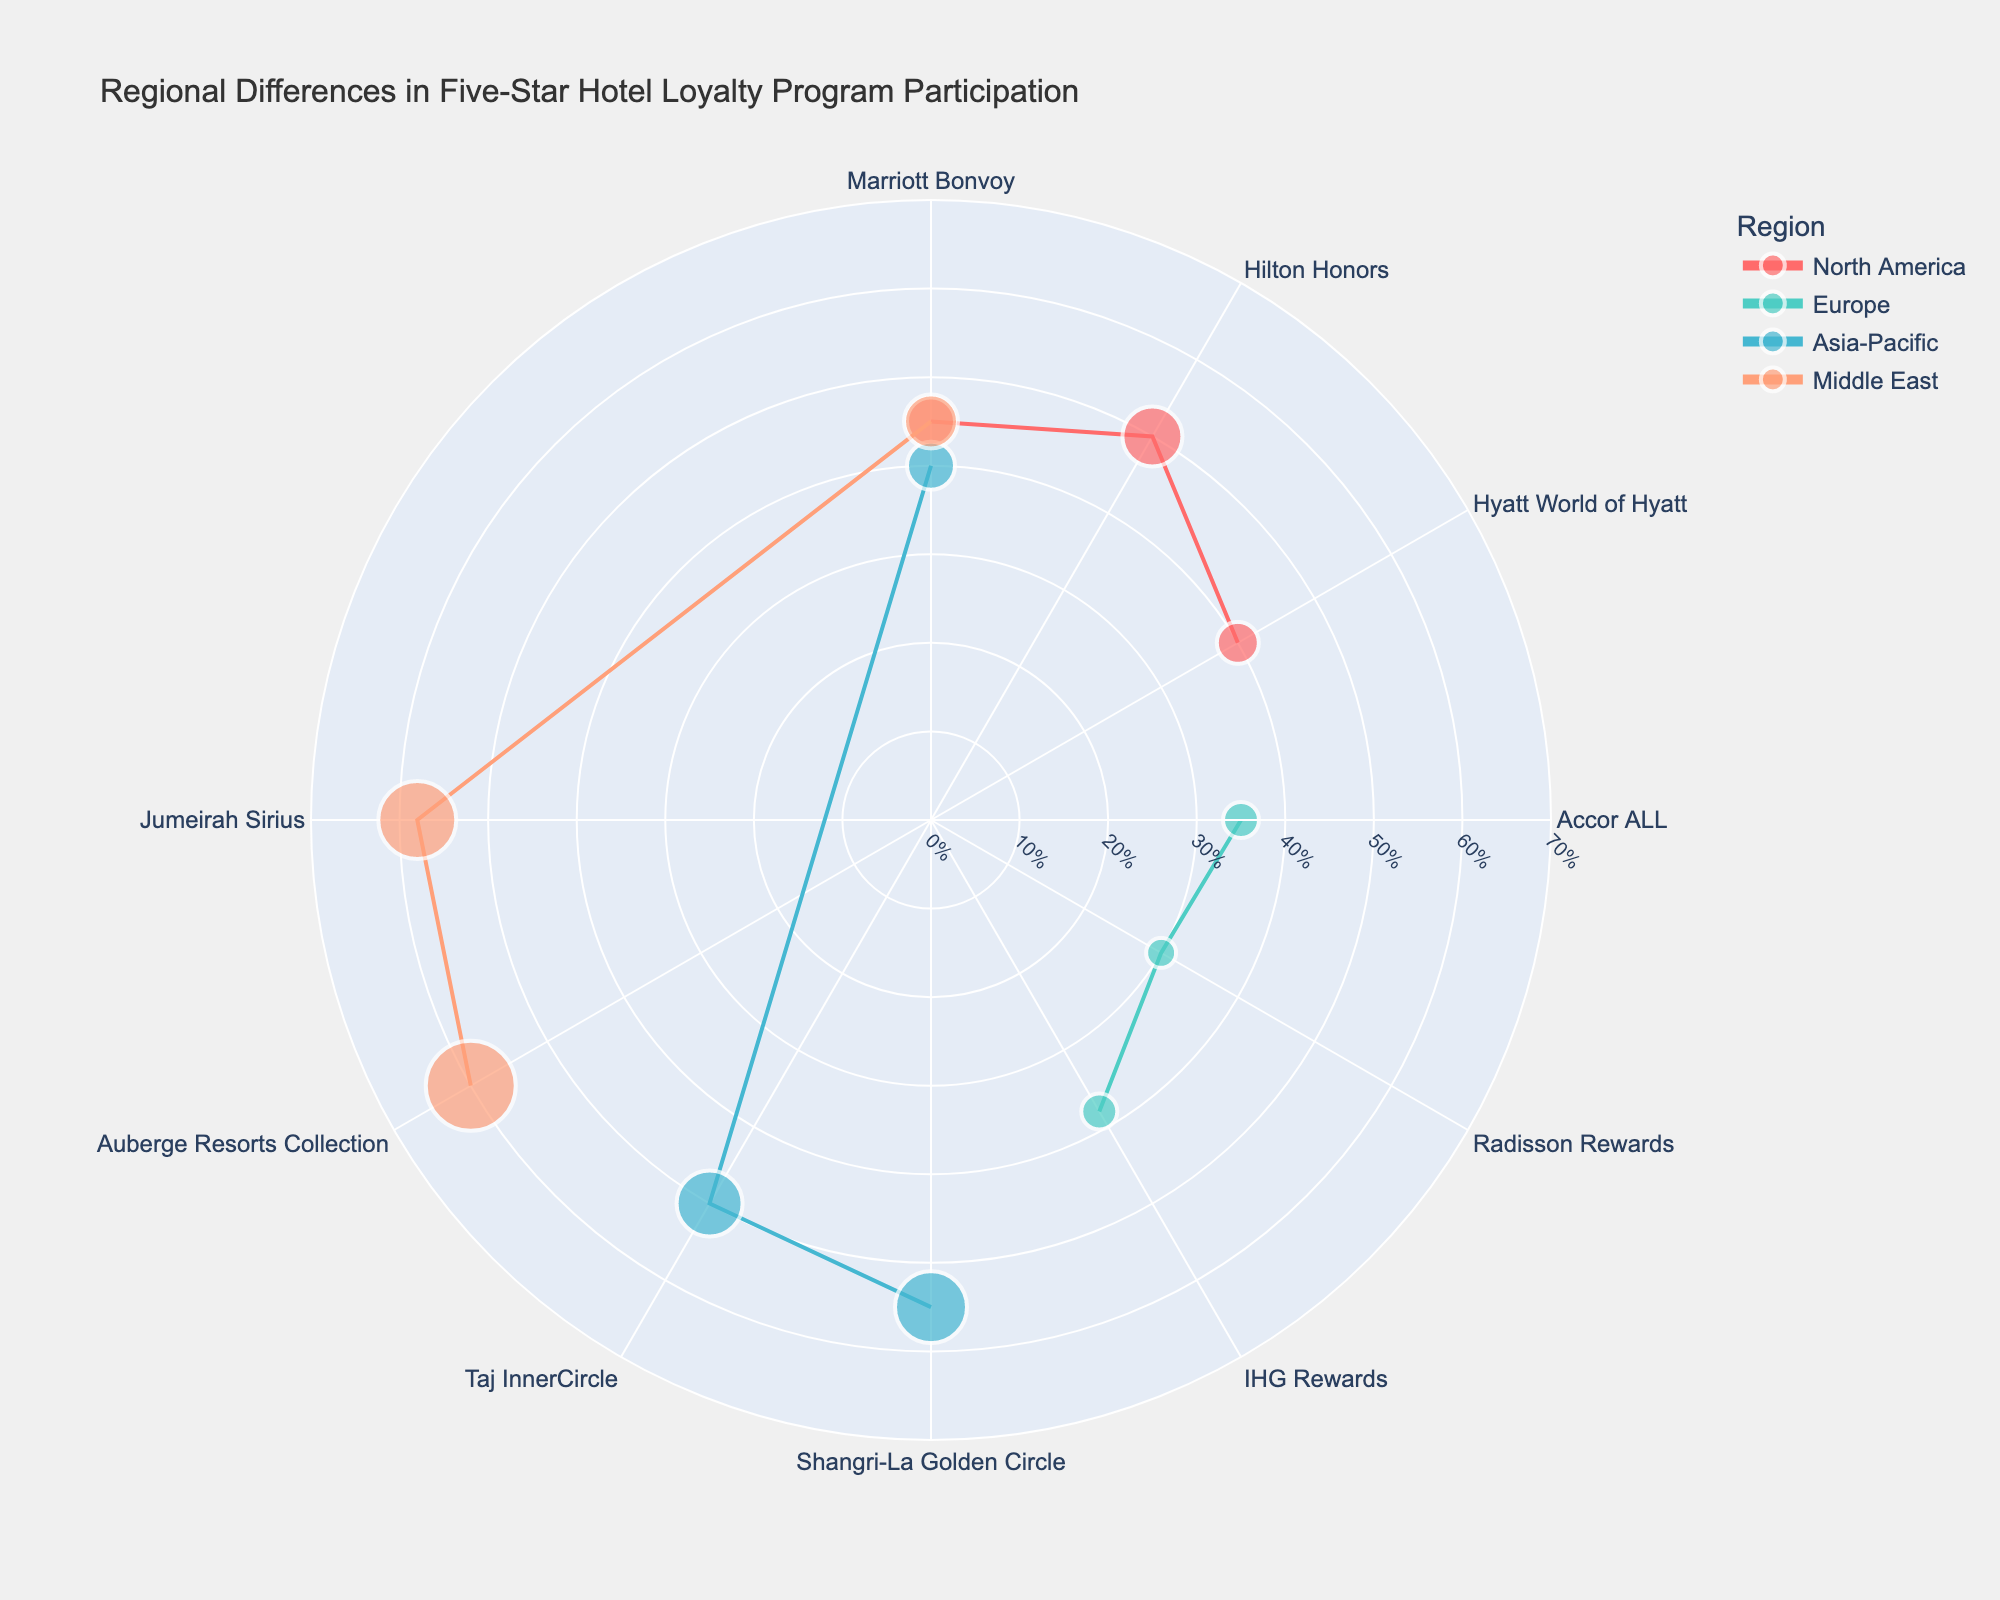What's the title of the chart? The title of the chart is usually displayed at the top of the figure. In this case, it's "Regional Differences in Five-Star Hotel Loyalty Program Participation".
Answer: Regional Differences in Five-Star Hotel Loyalty Program Participation How many hotels are represented in the figure for the Asia-Pacific region? To determine this, we look at the data points associated with the Asia-Pacific region. There are markers for Shangri-La Golden Circle, Taj InnerCircle, and Marriott Bonvoy. That's a total of three hotels.
Answer: Three Which hotel has the highest loyalty program participation in the Middle East region? Looking at the data points for the Middle East, we compare the participation percentages: Auberge Resorts Collection (60%), Jumeirah Sirius (58%), and Marriott Bonvoy (45%). Auberge Resorts Collection has the highest percentage.
Answer: Auberge Resorts Collection What is the average annual stays for hotels in the North America region? In the North America region, the hotels and their average annual stays are: Marriott Bonvoy (8), Hilton Honors (10), and Hyatt World of Hyatt (7). (8 + 10 + 7) / 3 = 8.33 on average.
Answer: 8.33 Which region has the highest average loyalty program participation? To find this, we average the program participation percentages for each region: North America (45%, 50%, 40%), Europe (35%, 30%, 38%), Asia-Pacific (55%, 50%, 40%), and Middle East (60%, 58%, 45%). North America: 45%, Europe: 34.33%, Asia-Pacific: 48.33%, Middle East: 54.33%. The highest is the Middle East.
Answer: Middle East What is the average loyalty program participation in Europe? We calculate the average for the participation percentages in Europe: Accor ALL (35%), Radisson Rewards (30%), and IHG Rewards (38%). (35 + 30 + 38) / 3 = 34.33%.
Answer: 34.33% How does the hotel with the lowest average annual stays in Europe compare to the highest in Asia-Pacific? The lowest in Europe is Radisson Rewards with 5 stays. The highest in Asia-Pacific is Shangri-La Golden Circle with 12 stays. The difference is 12 - 5 = 7 stays.
Answer: 7 stays Which region has the hotel with the most average annual stays, and what is that number? To determine this, we look at the highest average annual stays across all regions. In the Middle East, Auberge Resorts Collection has 15 stays which is the highest.
Answer: Middle East, 15 stays Which hotel in North America has the lowest loyalty program participation? We compare the participation percentages of the hotels in North America: Marriott Bonvoy (45%), Hilton Honors (50%), and Hyatt World of Hyatt (40%). The lowest is Hyatt World of Hyatt with 40%.
Answer: Hyatt World of Hyatt What is the relationship between average annual stays and program participation in the Asia-Pacific region? Analyzing the data points in Asia-Pacific: Shangri-La Golden Circle (55%, 12 stays), Taj InnerCircle (50%, 11 stays), and Marriott Bonvoy (40%, 8 stays), it seems there's a trend that higher program participation tends to align with more annual stays.
Answer: Positive correlation 